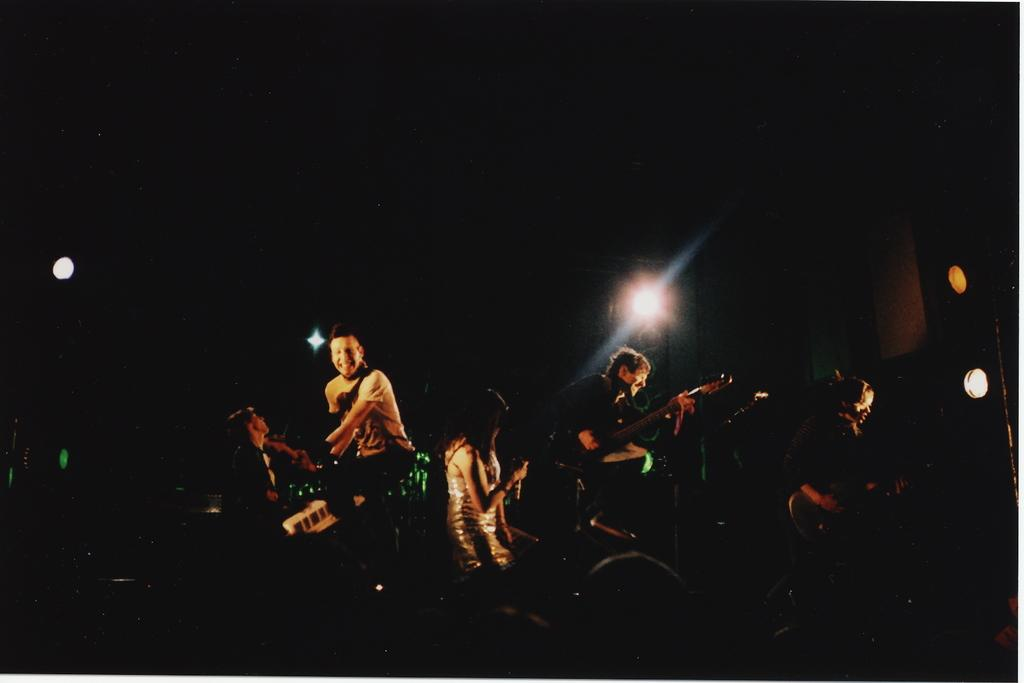What is happening in the image involving a group of people? The group of people in the image are playing musical instruments. What can be seen in the background of the image? There is a light visible in the background of the image. What type of committee can be seen in the image? There is no committee present in the image; it features a group of people playing musical instruments. What kind of cloud formation is visible in the image? There is no cloud formation visible in the image; it only shows a group of people playing musical instruments and a light in the background. 